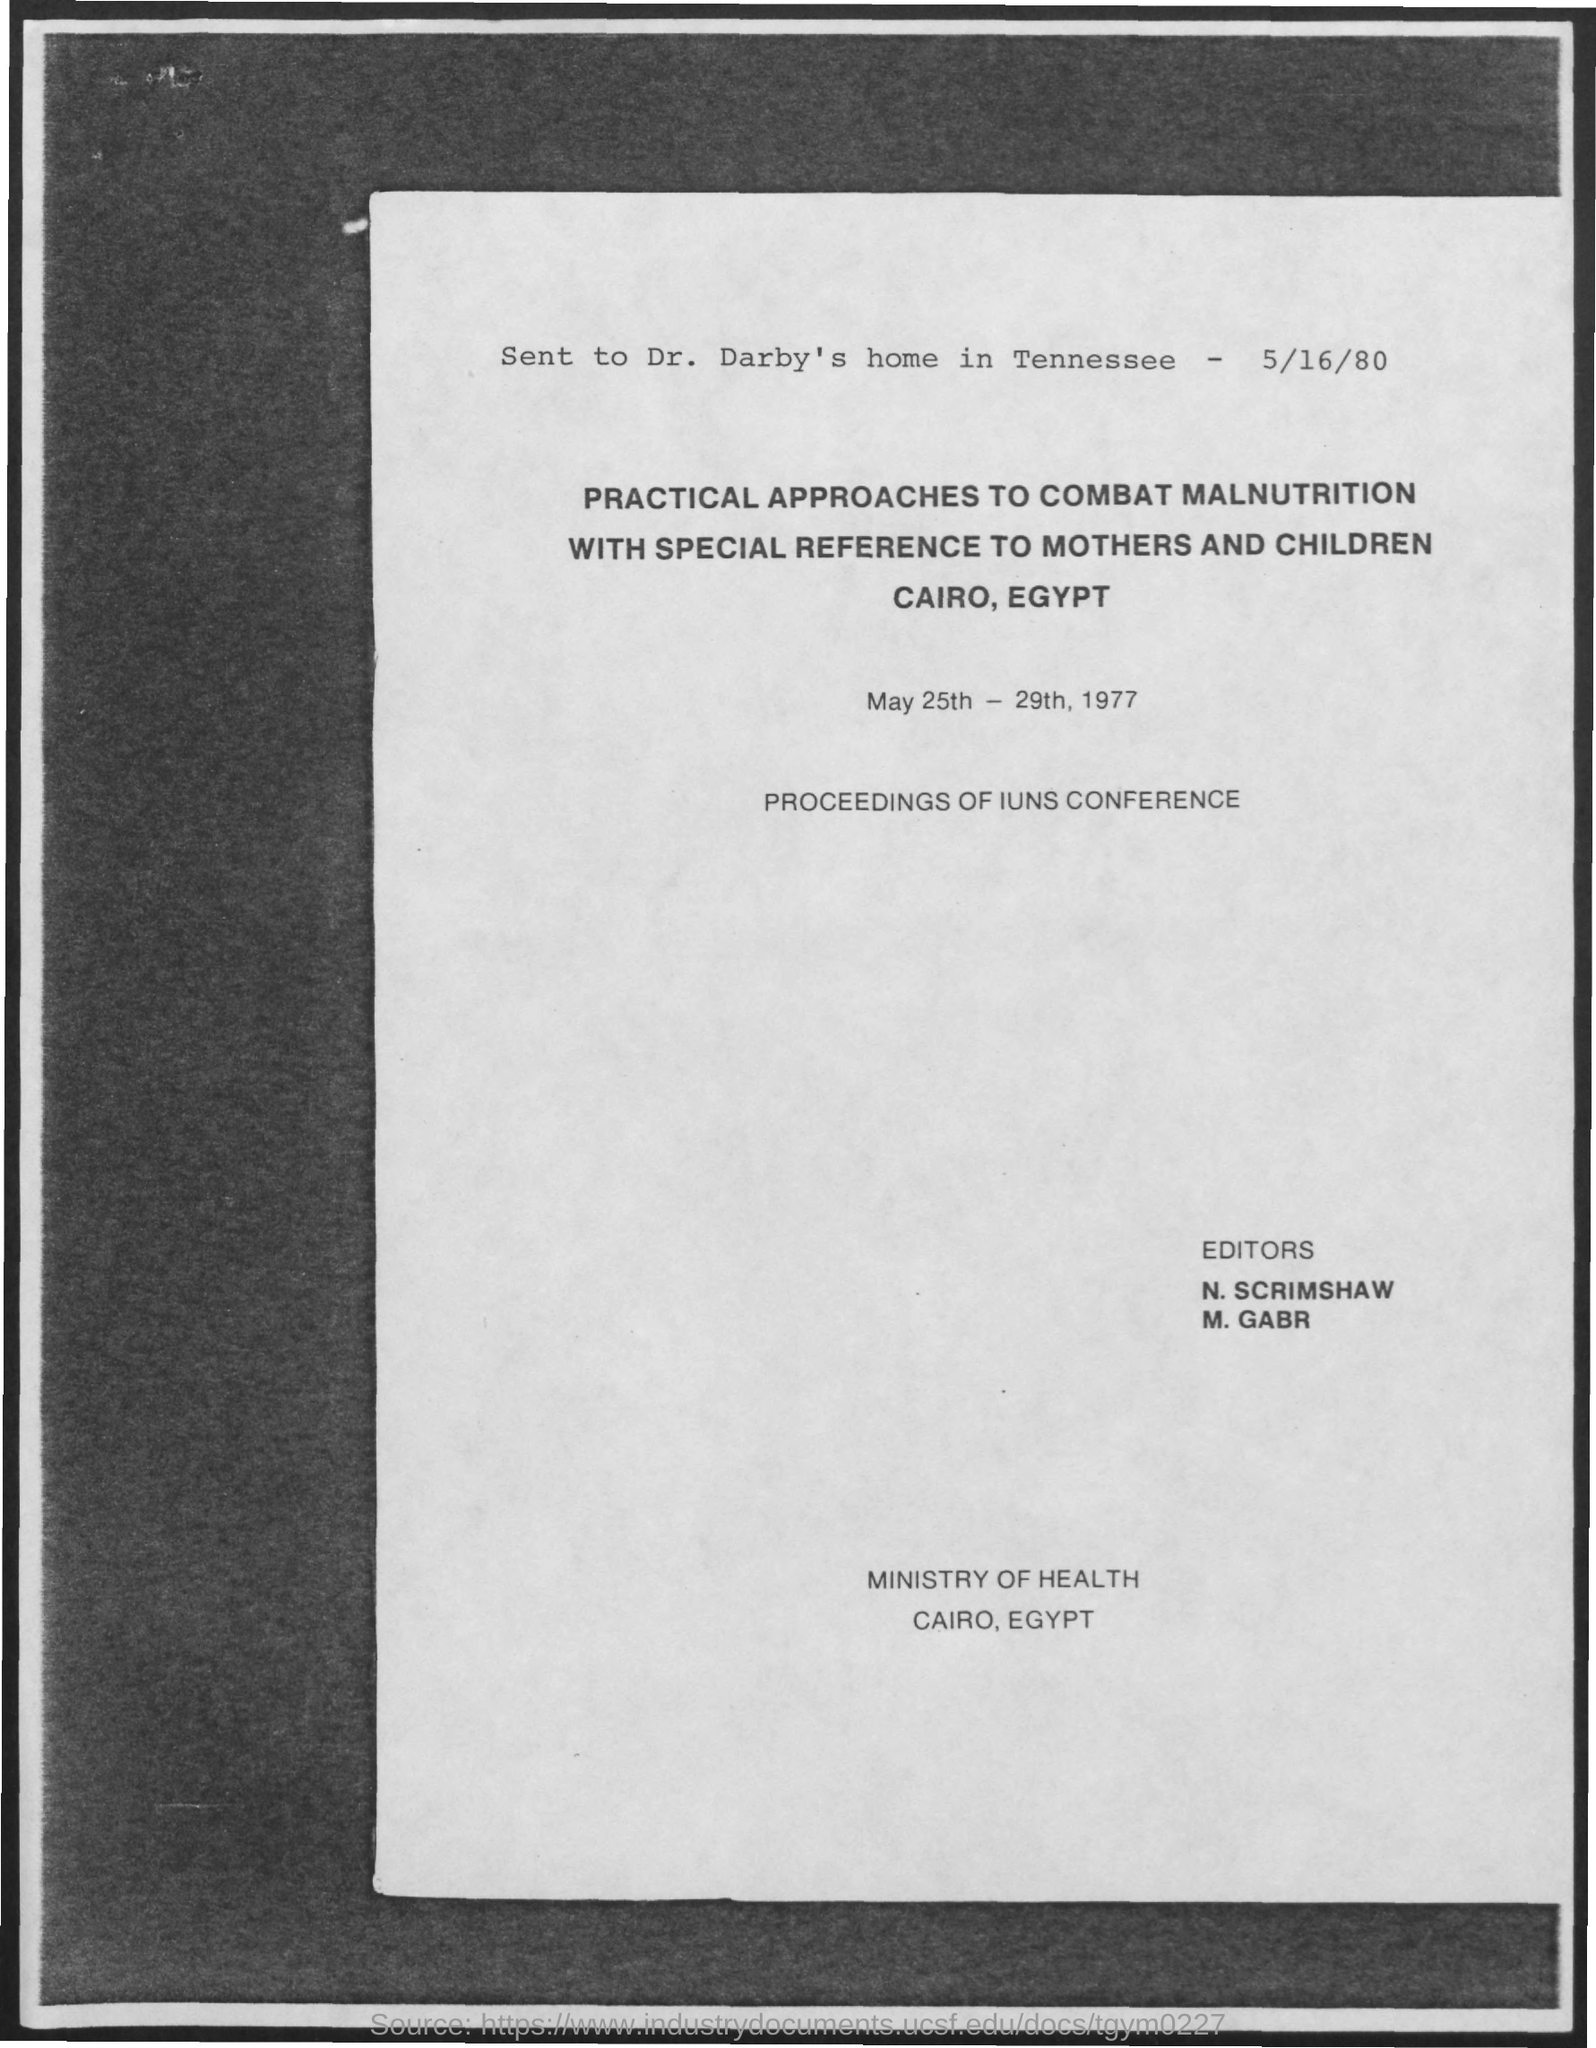Indicate a few pertinent items in this graphic. The Ministry of Health is located in Cairo, Egypt. The recipient of the message is Dr. Darby. The conference will take place from May 25th through May 29th, 1977. On what date was the message sent? The message was sent on May 16, 1980. 